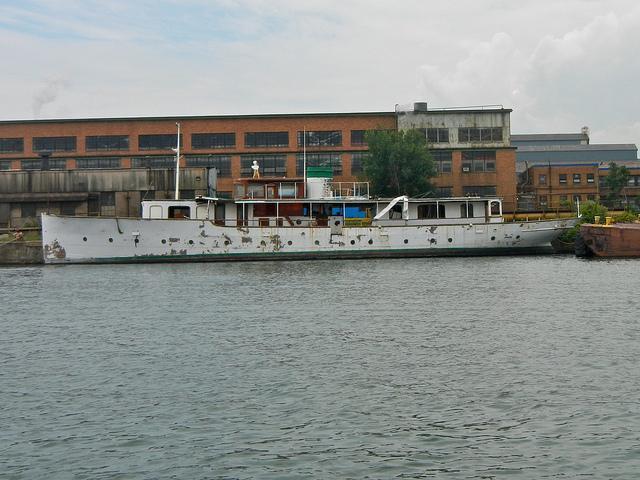How many ships are in the picture?
Give a very brief answer. 1. How many white buildings are in the background?
Give a very brief answer. 0. How many boats are there?
Give a very brief answer. 1. 